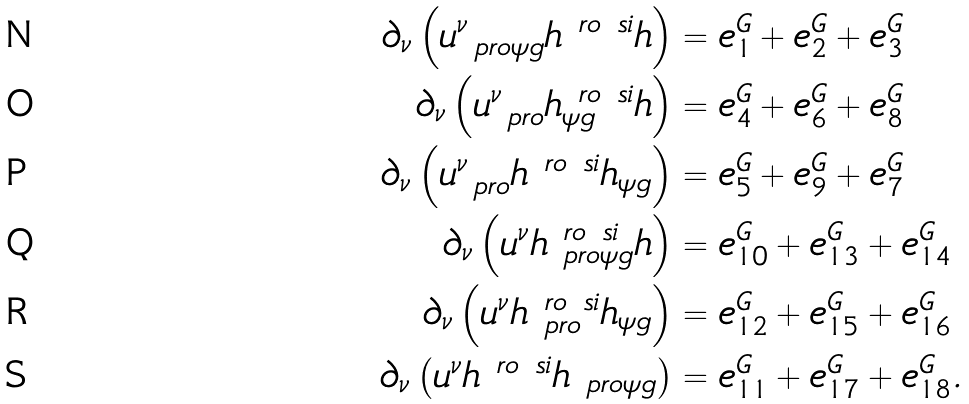<formula> <loc_0><loc_0><loc_500><loc_500>\partial _ { \nu } \left ( u ^ { \nu } _ { \ p r o \psi g } h ^ { \ r o \ s i } h \right ) & = e ^ { G } _ { 1 } + e ^ { G } _ { 2 } + e ^ { G } _ { 3 } \\ \partial _ { \nu } \left ( u ^ { \nu } _ { \ p r o } h ^ { \ r o \ s i } _ { \psi g } h \right ) & = e ^ { G } _ { 4 } + e ^ { G } _ { 6 } + e ^ { G } _ { 8 } \\ \partial _ { \nu } \left ( u ^ { \nu } _ { \ p r o } h ^ { \ r o \ s i } h _ { \psi g } \right ) & = e ^ { G } _ { 5 } + e ^ { G } _ { 9 } + e ^ { G } _ { 7 } \\ \partial _ { \nu } \left ( u ^ { \nu } h ^ { \ r o \ s i } _ { \ p r o \psi g } h \right ) & = e ^ { G } _ { 1 0 } + e ^ { G } _ { 1 3 } + e ^ { G } _ { 1 4 } \\ \partial _ { \nu } \left ( u ^ { \nu } h ^ { \ r o \ s i } _ { \ p r o } h _ { \psi g } \right ) & = e ^ { G } _ { 1 2 } + e ^ { G } _ { 1 5 } + e ^ { G } _ { 1 6 } \\ \partial _ { \nu } \left ( u ^ { \nu } h ^ { \ r o \ s i } h _ { \ p r o \psi g } \right ) & = e ^ { G } _ { 1 1 } + e ^ { G } _ { 1 7 } + e ^ { G } _ { 1 8 } .</formula> 